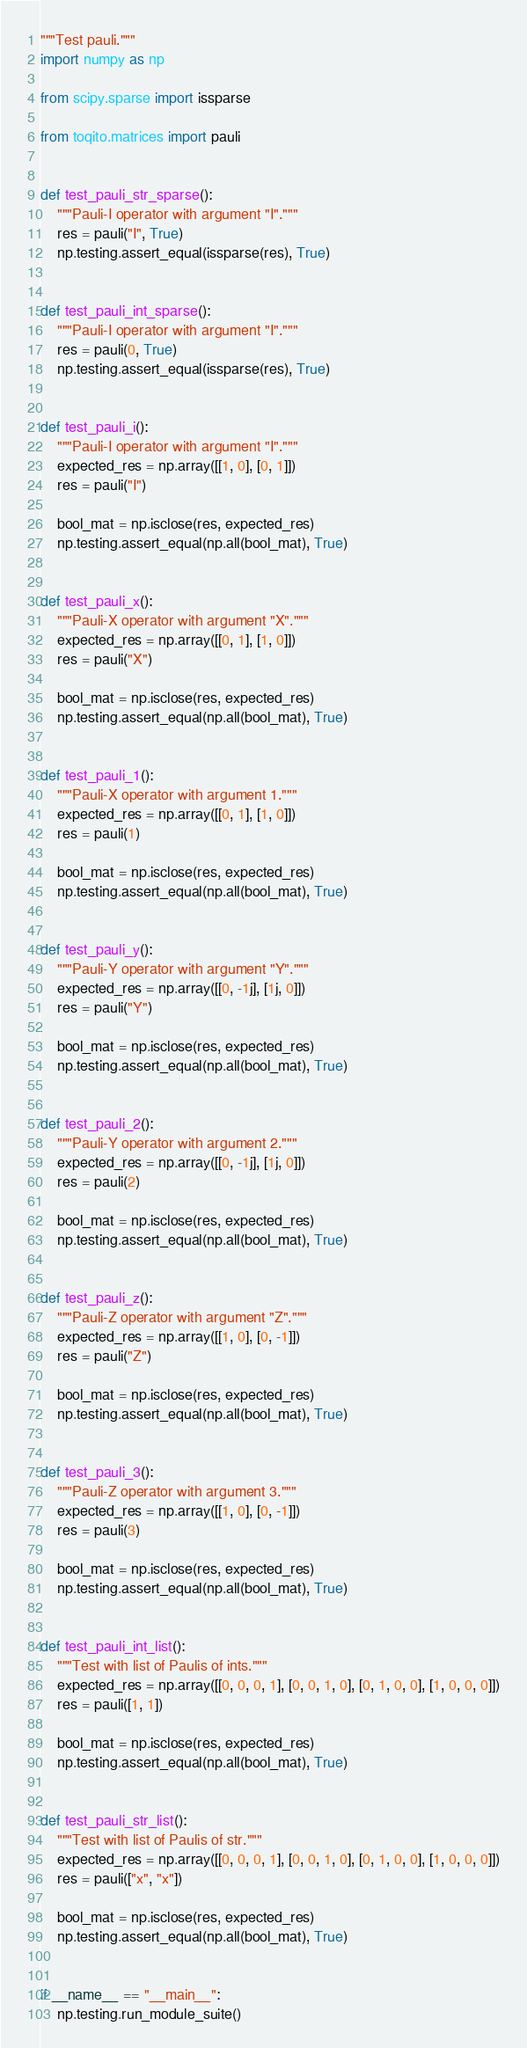Convert code to text. <code><loc_0><loc_0><loc_500><loc_500><_Python_>"""Test pauli."""
import numpy as np

from scipy.sparse import issparse

from toqito.matrices import pauli


def test_pauli_str_sparse():
    """Pauli-I operator with argument "I"."""
    res = pauli("I", True)
    np.testing.assert_equal(issparse(res), True)


def test_pauli_int_sparse():
    """Pauli-I operator with argument "I"."""
    res = pauli(0, True)
    np.testing.assert_equal(issparse(res), True)


def test_pauli_i():
    """Pauli-I operator with argument "I"."""
    expected_res = np.array([[1, 0], [0, 1]])
    res = pauli("I")

    bool_mat = np.isclose(res, expected_res)
    np.testing.assert_equal(np.all(bool_mat), True)


def test_pauli_x():
    """Pauli-X operator with argument "X"."""
    expected_res = np.array([[0, 1], [1, 0]])
    res = pauli("X")

    bool_mat = np.isclose(res, expected_res)
    np.testing.assert_equal(np.all(bool_mat), True)


def test_pauli_1():
    """Pauli-X operator with argument 1."""
    expected_res = np.array([[0, 1], [1, 0]])
    res = pauli(1)

    bool_mat = np.isclose(res, expected_res)
    np.testing.assert_equal(np.all(bool_mat), True)


def test_pauli_y():
    """Pauli-Y operator with argument "Y"."""
    expected_res = np.array([[0, -1j], [1j, 0]])
    res = pauli("Y")

    bool_mat = np.isclose(res, expected_res)
    np.testing.assert_equal(np.all(bool_mat), True)


def test_pauli_2():
    """Pauli-Y operator with argument 2."""
    expected_res = np.array([[0, -1j], [1j, 0]])
    res = pauli(2)

    bool_mat = np.isclose(res, expected_res)
    np.testing.assert_equal(np.all(bool_mat), True)


def test_pauli_z():
    """Pauli-Z operator with argument "Z"."""
    expected_res = np.array([[1, 0], [0, -1]])
    res = pauli("Z")

    bool_mat = np.isclose(res, expected_res)
    np.testing.assert_equal(np.all(bool_mat), True)


def test_pauli_3():
    """Pauli-Z operator with argument 3."""
    expected_res = np.array([[1, 0], [0, -1]])
    res = pauli(3)

    bool_mat = np.isclose(res, expected_res)
    np.testing.assert_equal(np.all(bool_mat), True)


def test_pauli_int_list():
    """Test with list of Paulis of ints."""
    expected_res = np.array([[0, 0, 0, 1], [0, 0, 1, 0], [0, 1, 0, 0], [1, 0, 0, 0]])
    res = pauli([1, 1])

    bool_mat = np.isclose(res, expected_res)
    np.testing.assert_equal(np.all(bool_mat), True)


def test_pauli_str_list():
    """Test with list of Paulis of str."""
    expected_res = np.array([[0, 0, 0, 1], [0, 0, 1, 0], [0, 1, 0, 0], [1, 0, 0, 0]])
    res = pauli(["x", "x"])

    bool_mat = np.isclose(res, expected_res)
    np.testing.assert_equal(np.all(bool_mat), True)


if __name__ == "__main__":
    np.testing.run_module_suite()
</code> 